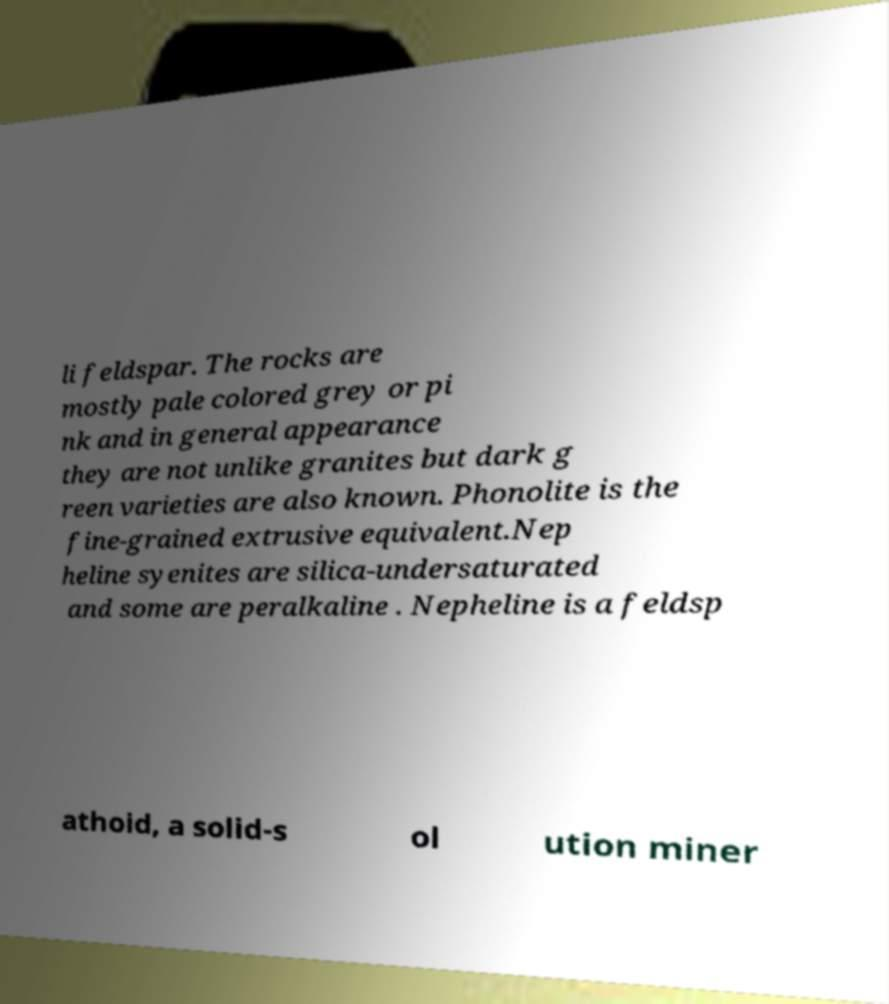Can you accurately transcribe the text from the provided image for me? li feldspar. The rocks are mostly pale colored grey or pi nk and in general appearance they are not unlike granites but dark g reen varieties are also known. Phonolite is the fine-grained extrusive equivalent.Nep heline syenites are silica-undersaturated and some are peralkaline . Nepheline is a feldsp athoid, a solid-s ol ution miner 